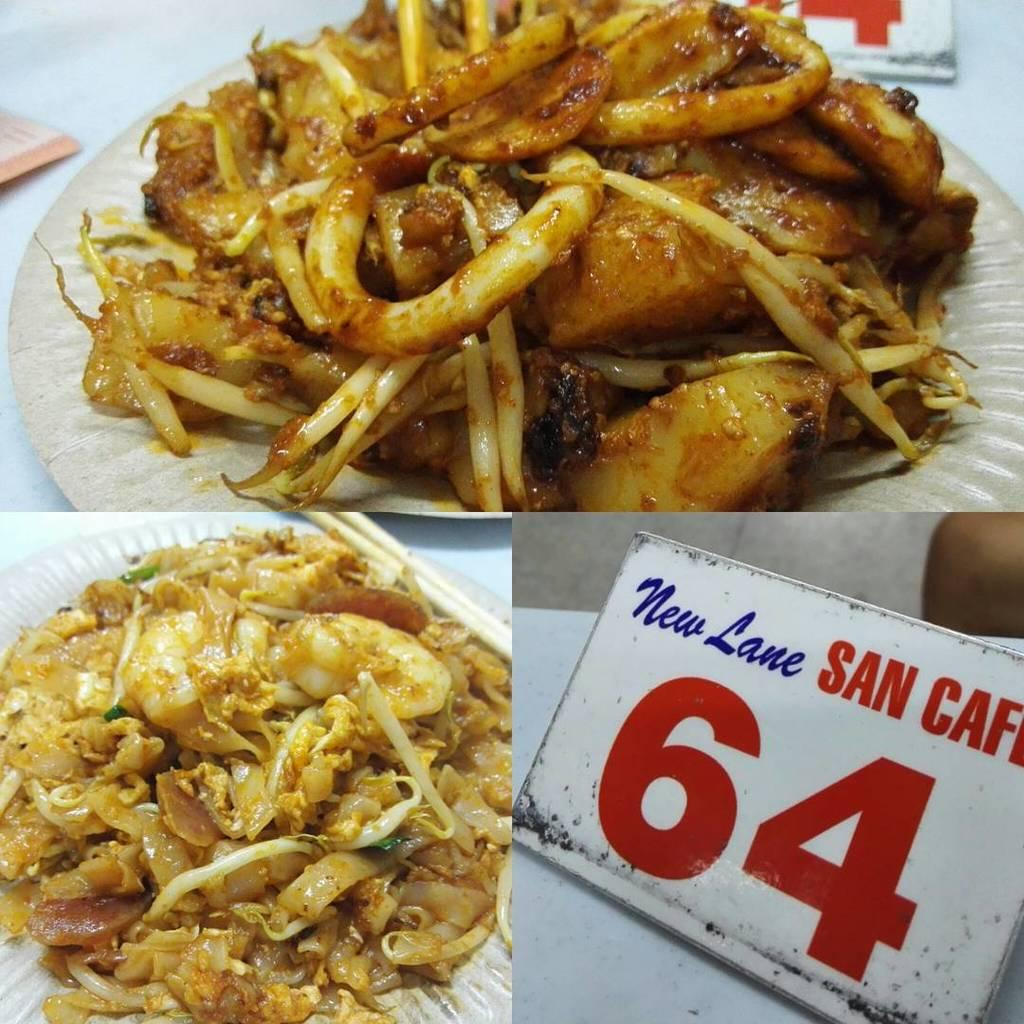What type of image is being described? The image is a collage of different pictures. Can you describe any specific elements within the collage? Yes, there is a board visible in one of the pictures, and there is food visible in another picture. What type of shoe is being worn by the minister in the image? There is no minister or shoe present in the image. How many buckets are visible in the image? There are no buckets visible in the image. 